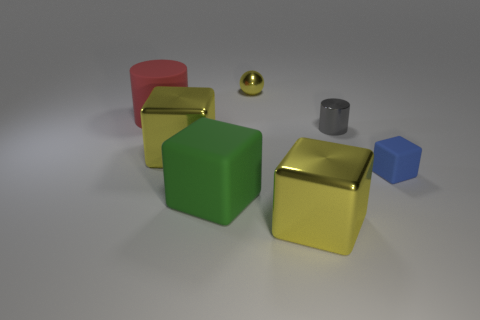How are the objects arranged in relation to each other? The objects are arranged on a flat surface with spaces between them. They are placed seemingly at random, with no apparent pattern or alignment. The small blue cube and the tiny grey cylinder seem to be slightly isolated from the group of larger, shiny blocks. 